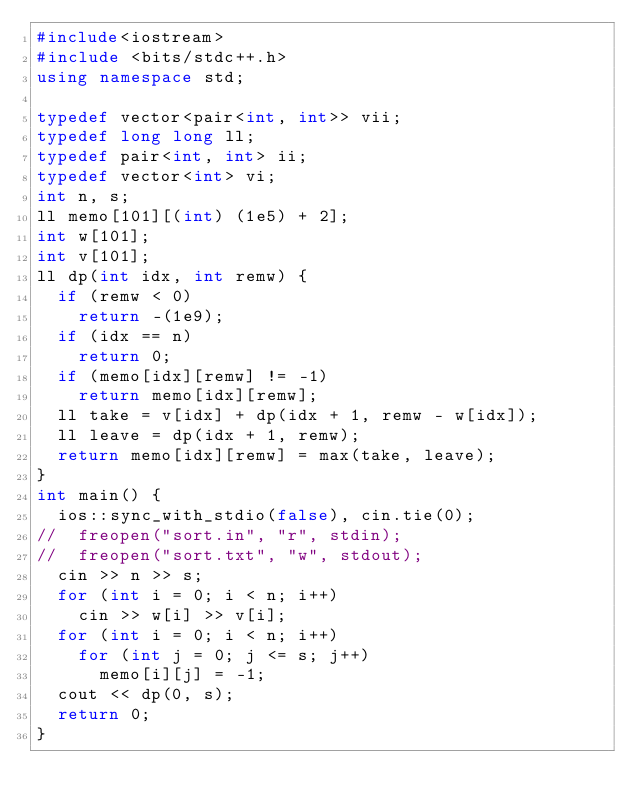Convert code to text. <code><loc_0><loc_0><loc_500><loc_500><_C++_>#include<iostream>
#include <bits/stdc++.h>
using namespace std;

typedef vector<pair<int, int>> vii;
typedef long long ll;
typedef pair<int, int> ii;
typedef vector<int> vi;
int n, s;
ll memo[101][(int) (1e5) + 2];
int w[101];
int v[101];
ll dp(int idx, int remw) {
	if (remw < 0)
		return -(1e9);
	if (idx == n)
		return 0;
	if (memo[idx][remw] != -1)
		return memo[idx][remw];
	ll take = v[idx] + dp(idx + 1, remw - w[idx]);
	ll leave = dp(idx + 1, remw);
	return memo[idx][remw] = max(take, leave);
}
int main() {
	ios::sync_with_stdio(false), cin.tie(0);
//	freopen("sort.in", "r", stdin);
//	freopen("sort.txt", "w", stdout);
	cin >> n >> s;
	for (int i = 0; i < n; i++)
		cin >> w[i] >> v[i];
	for (int i = 0; i < n; i++)
		for (int j = 0; j <= s; j++)
			memo[i][j] = -1;
	cout << dp(0, s);
	return 0;
}

</code> 